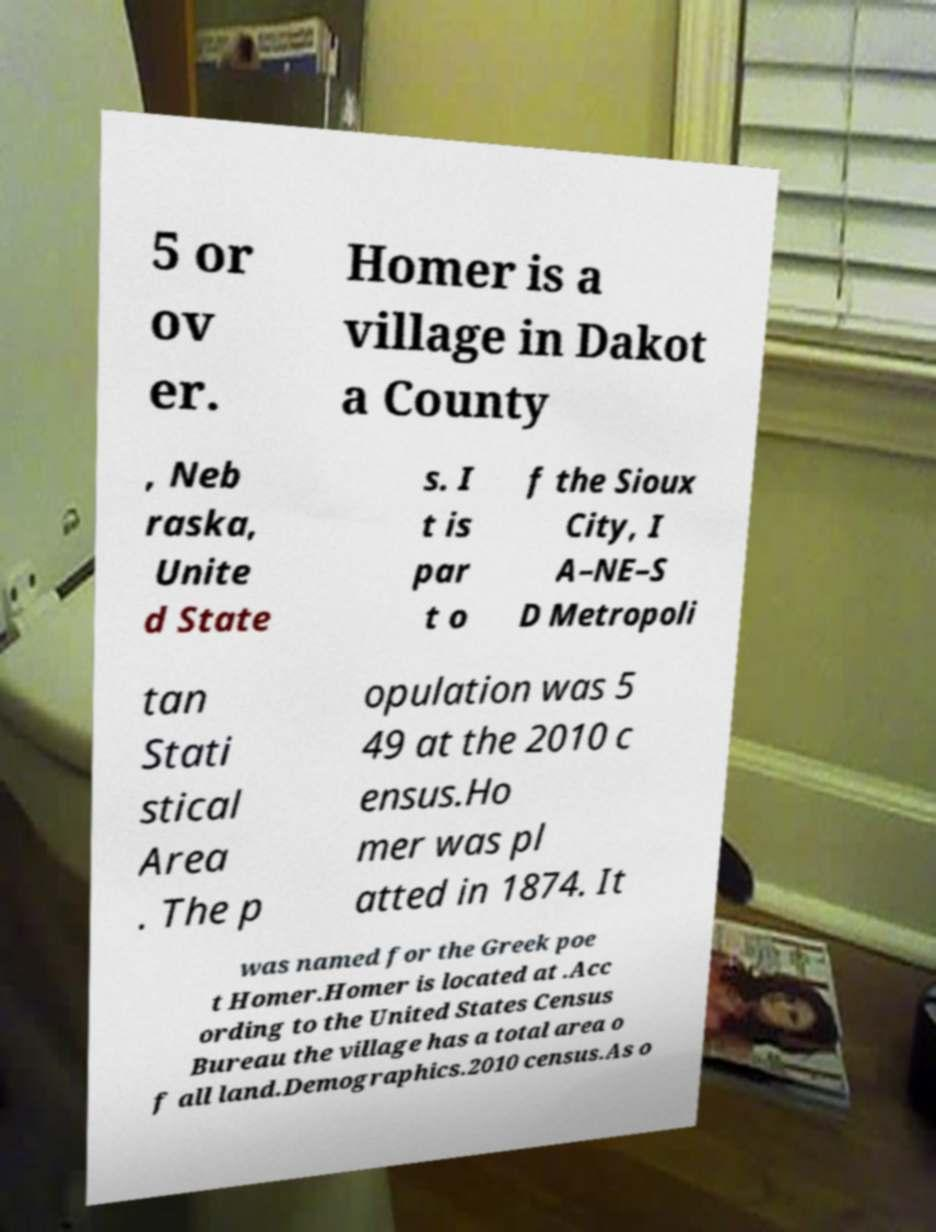Please read and relay the text visible in this image. What does it say? 5 or ov er. Homer is a village in Dakot a County , Neb raska, Unite d State s. I t is par t o f the Sioux City, I A–NE–S D Metropoli tan Stati stical Area . The p opulation was 5 49 at the 2010 c ensus.Ho mer was pl atted in 1874. It was named for the Greek poe t Homer.Homer is located at .Acc ording to the United States Census Bureau the village has a total area o f all land.Demographics.2010 census.As o 